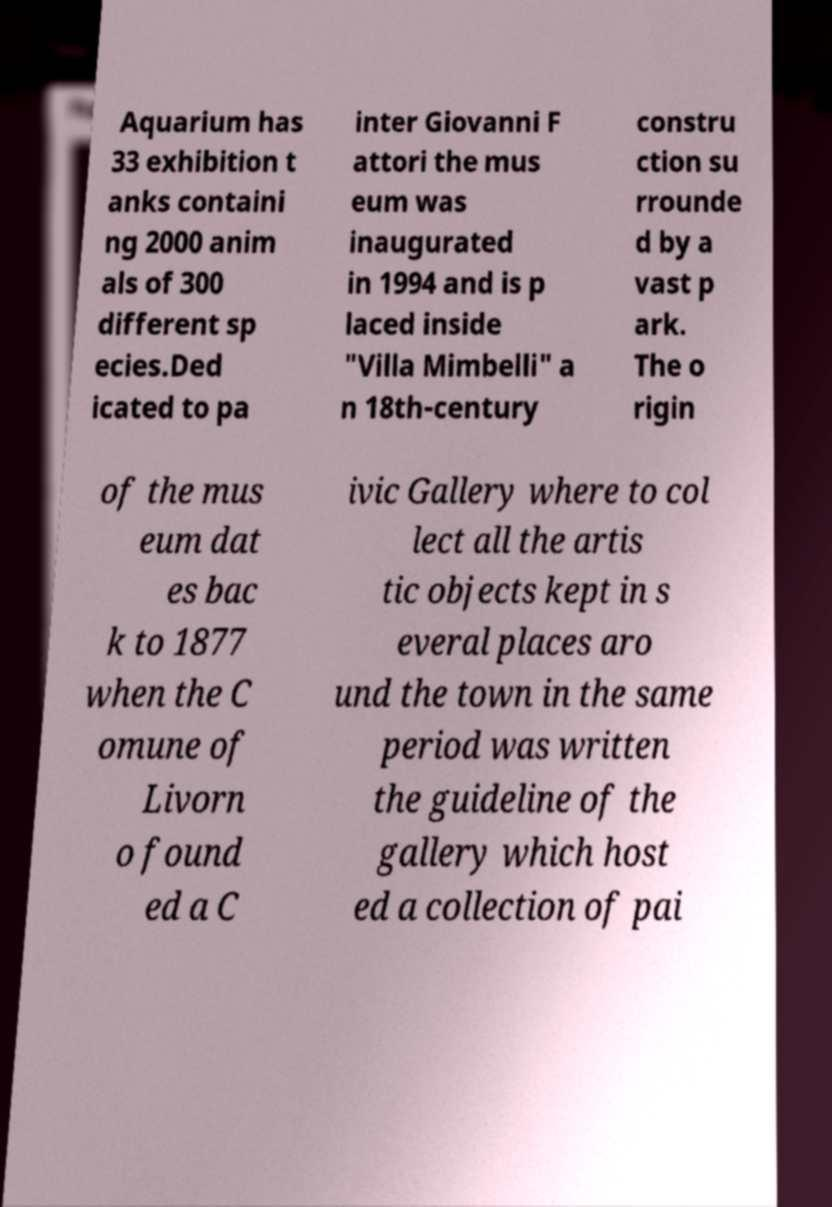Can you read and provide the text displayed in the image?This photo seems to have some interesting text. Can you extract and type it out for me? Aquarium has 33 exhibition t anks containi ng 2000 anim als of 300 different sp ecies.Ded icated to pa inter Giovanni F attori the mus eum was inaugurated in 1994 and is p laced inside "Villa Mimbelli" a n 18th-century constru ction su rrounde d by a vast p ark. The o rigin of the mus eum dat es bac k to 1877 when the C omune of Livorn o found ed a C ivic Gallery where to col lect all the artis tic objects kept in s everal places aro und the town in the same period was written the guideline of the gallery which host ed a collection of pai 